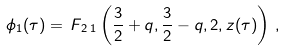Convert formula to latex. <formula><loc_0><loc_0><loc_500><loc_500>\phi _ { 1 } ( \tau ) = \, F _ { \, 2 \, 1 } \left ( \frac { 3 } { 2 } + q , \frac { 3 } { 2 } - q , 2 , z ( \tau ) \right ) \, ,</formula> 